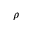Convert formula to latex. <formula><loc_0><loc_0><loc_500><loc_500>\rho</formula> 